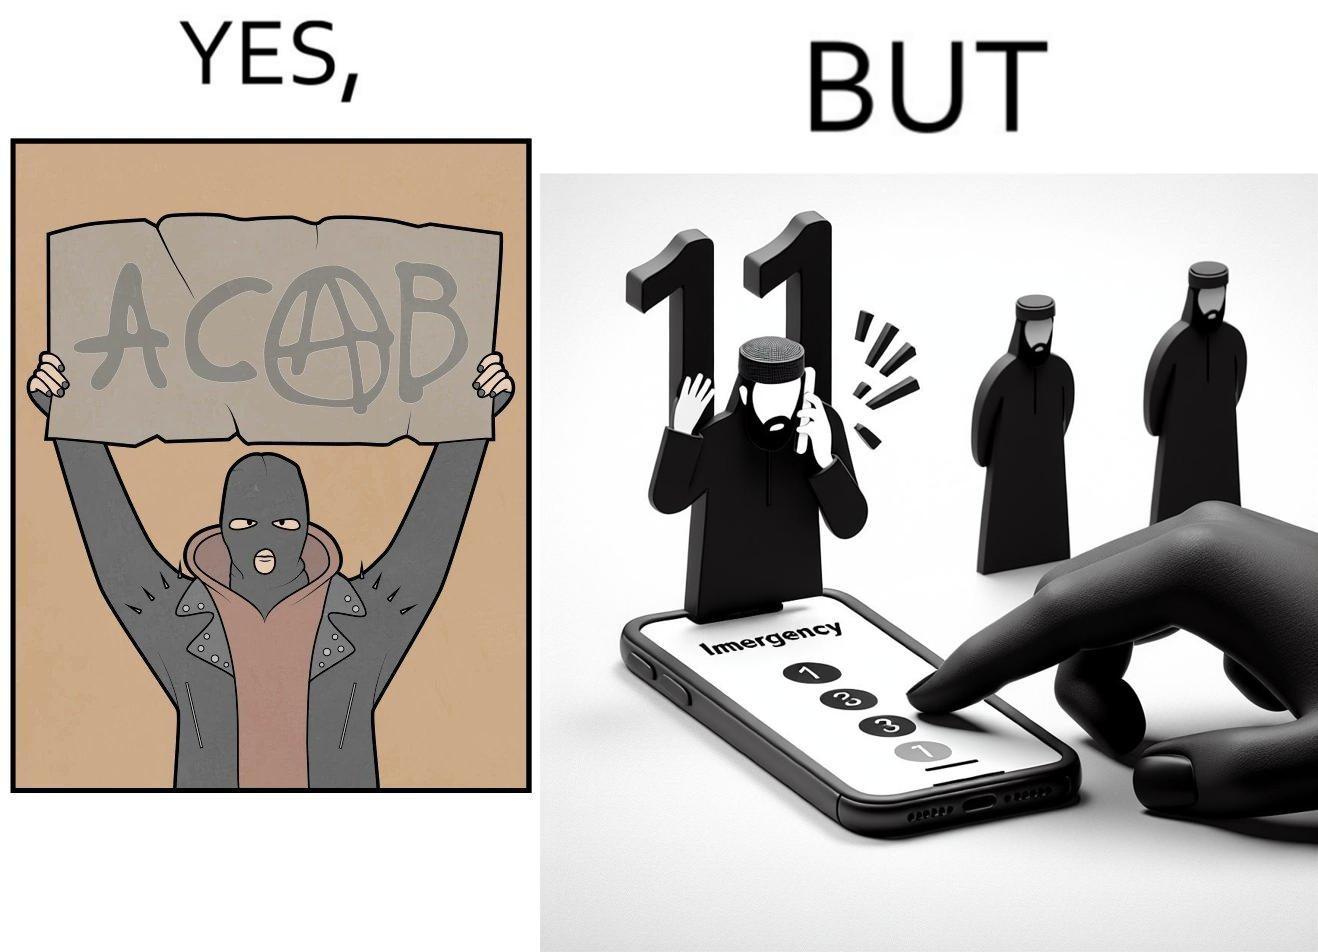Describe the contrast between the left and right parts of this image. In the left part of the image: A person holding a sign that says the letters ACAB. The persons face is covered by a mask, they have black nails and they looks like they are protesting something. In the right part of the image: Person dialling 112 Emergency number on their phone. They have black nails 